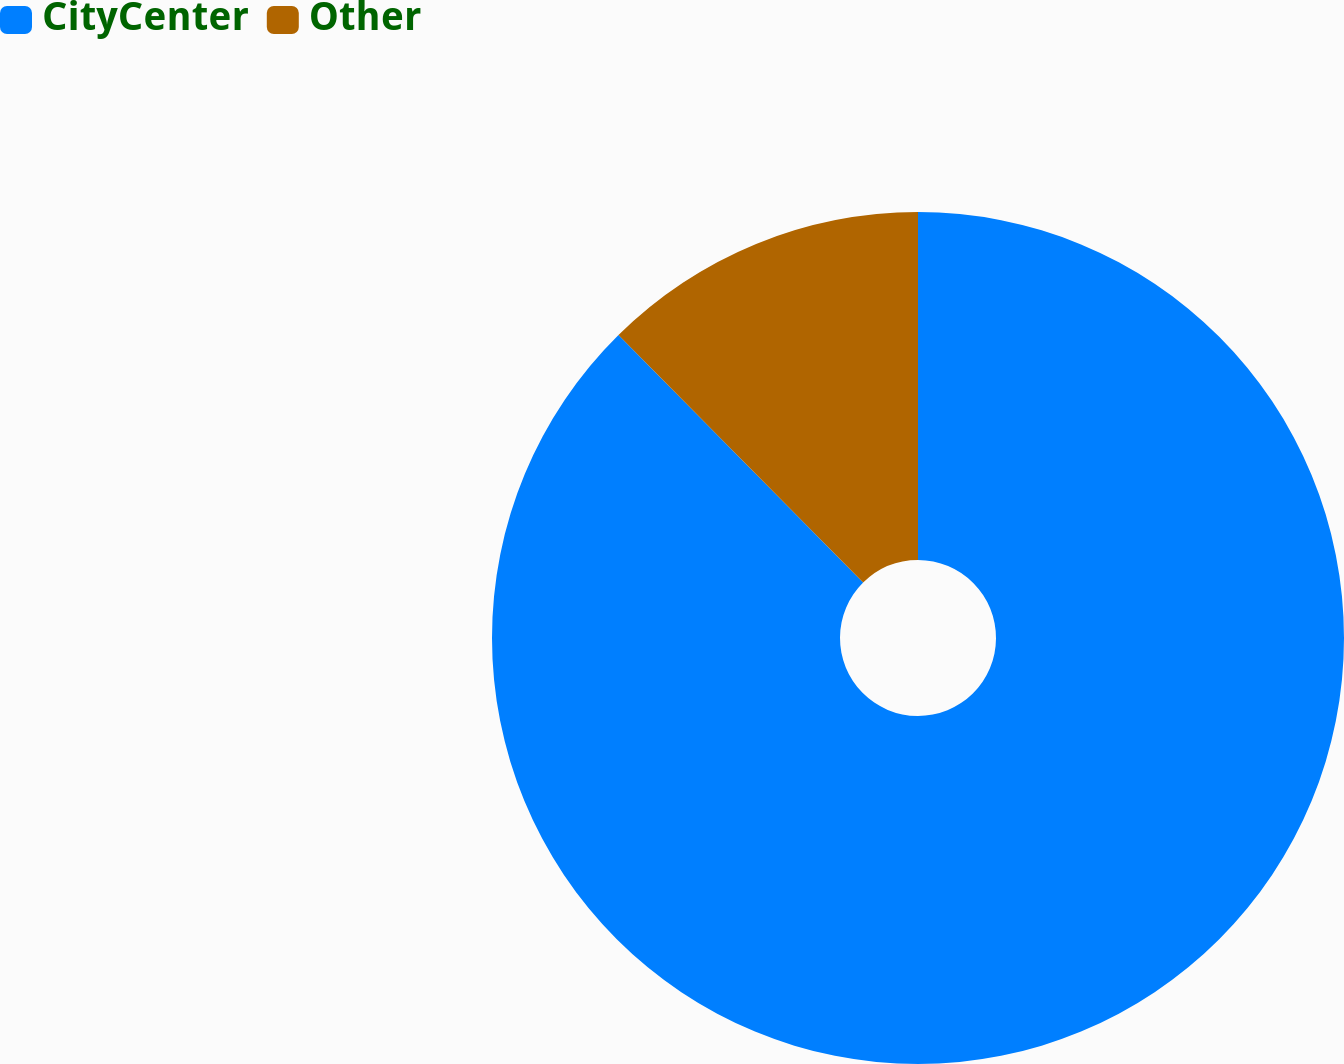Convert chart to OTSL. <chart><loc_0><loc_0><loc_500><loc_500><pie_chart><fcel>CityCenter<fcel>Other<nl><fcel>87.59%<fcel>12.41%<nl></chart> 